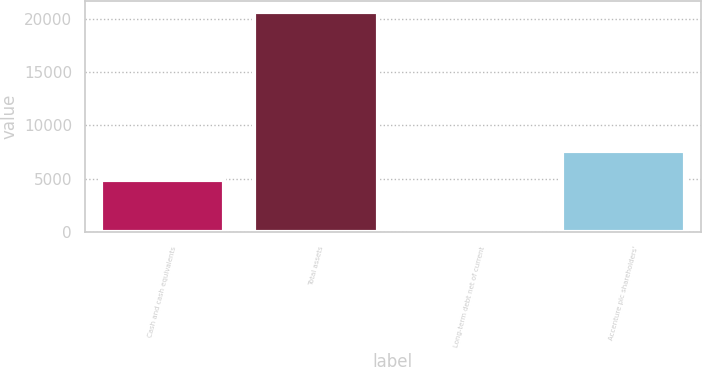Convert chart. <chart><loc_0><loc_0><loc_500><loc_500><bar_chart><fcel>Cash and cash equivalents<fcel>Total assets<fcel>Long-term debt net of current<fcel>Accenture plc shareholders'<nl><fcel>4906<fcel>20609<fcel>24<fcel>7555<nl></chart> 